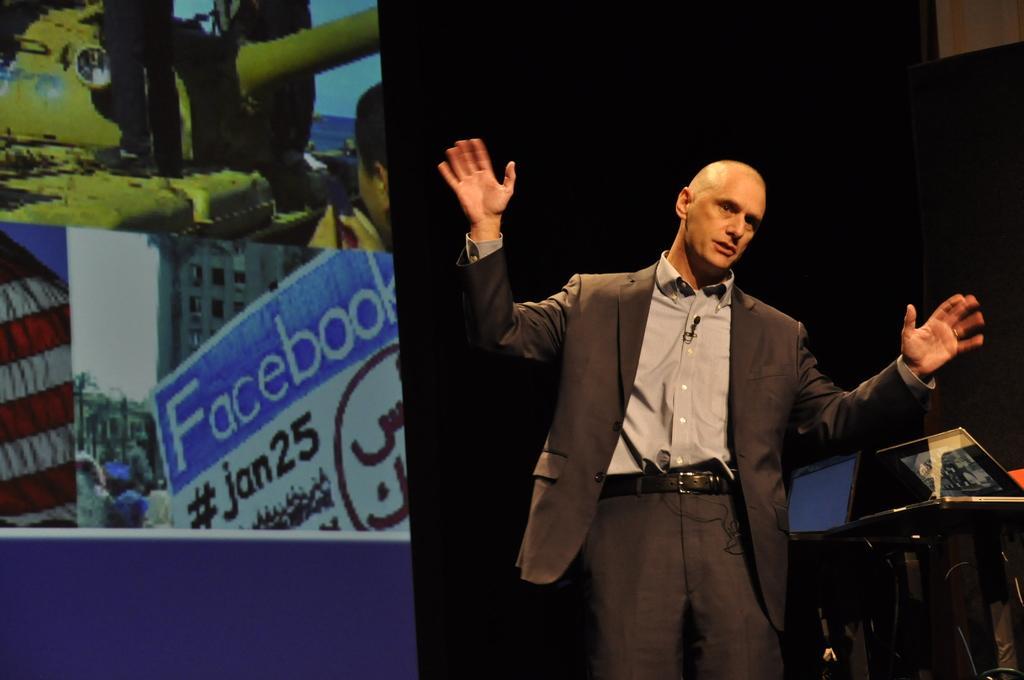Could you give a brief overview of what you see in this image? In this picture we can see a man wore a blazer and standing and beside him we can see laptops on stands, screen and in the background it is dark. 